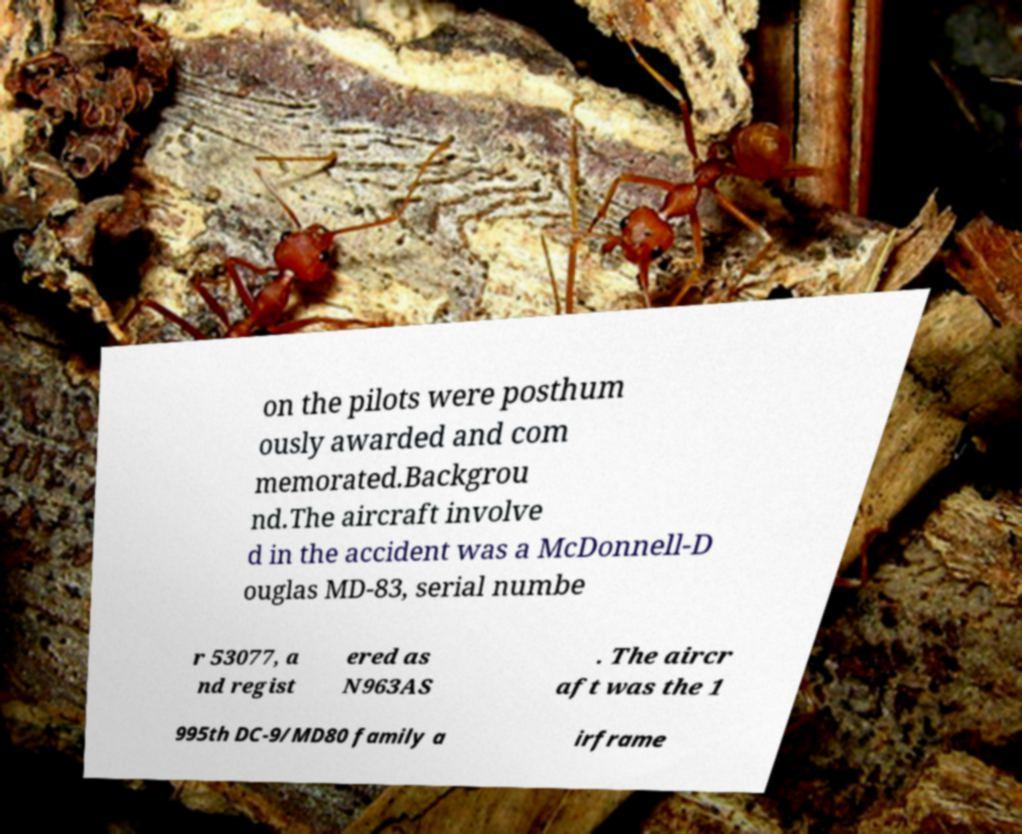Can you read and provide the text displayed in the image?This photo seems to have some interesting text. Can you extract and type it out for me? on the pilots were posthum ously awarded and com memorated.Backgrou nd.The aircraft involve d in the accident was a McDonnell-D ouglas MD-83, serial numbe r 53077, a nd regist ered as N963AS . The aircr aft was the 1 995th DC-9/MD80 family a irframe 